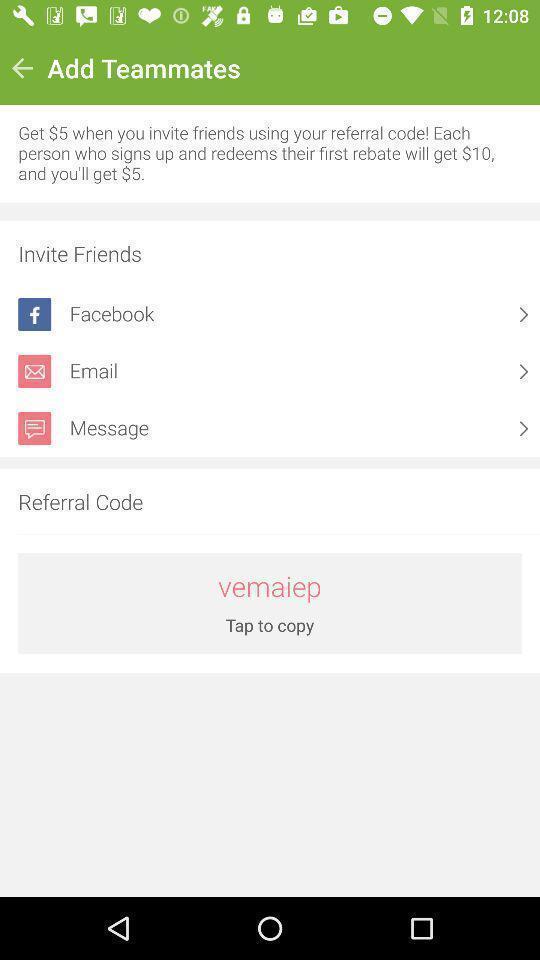Describe the content in this image. Page shows to invite your friends in social app. 